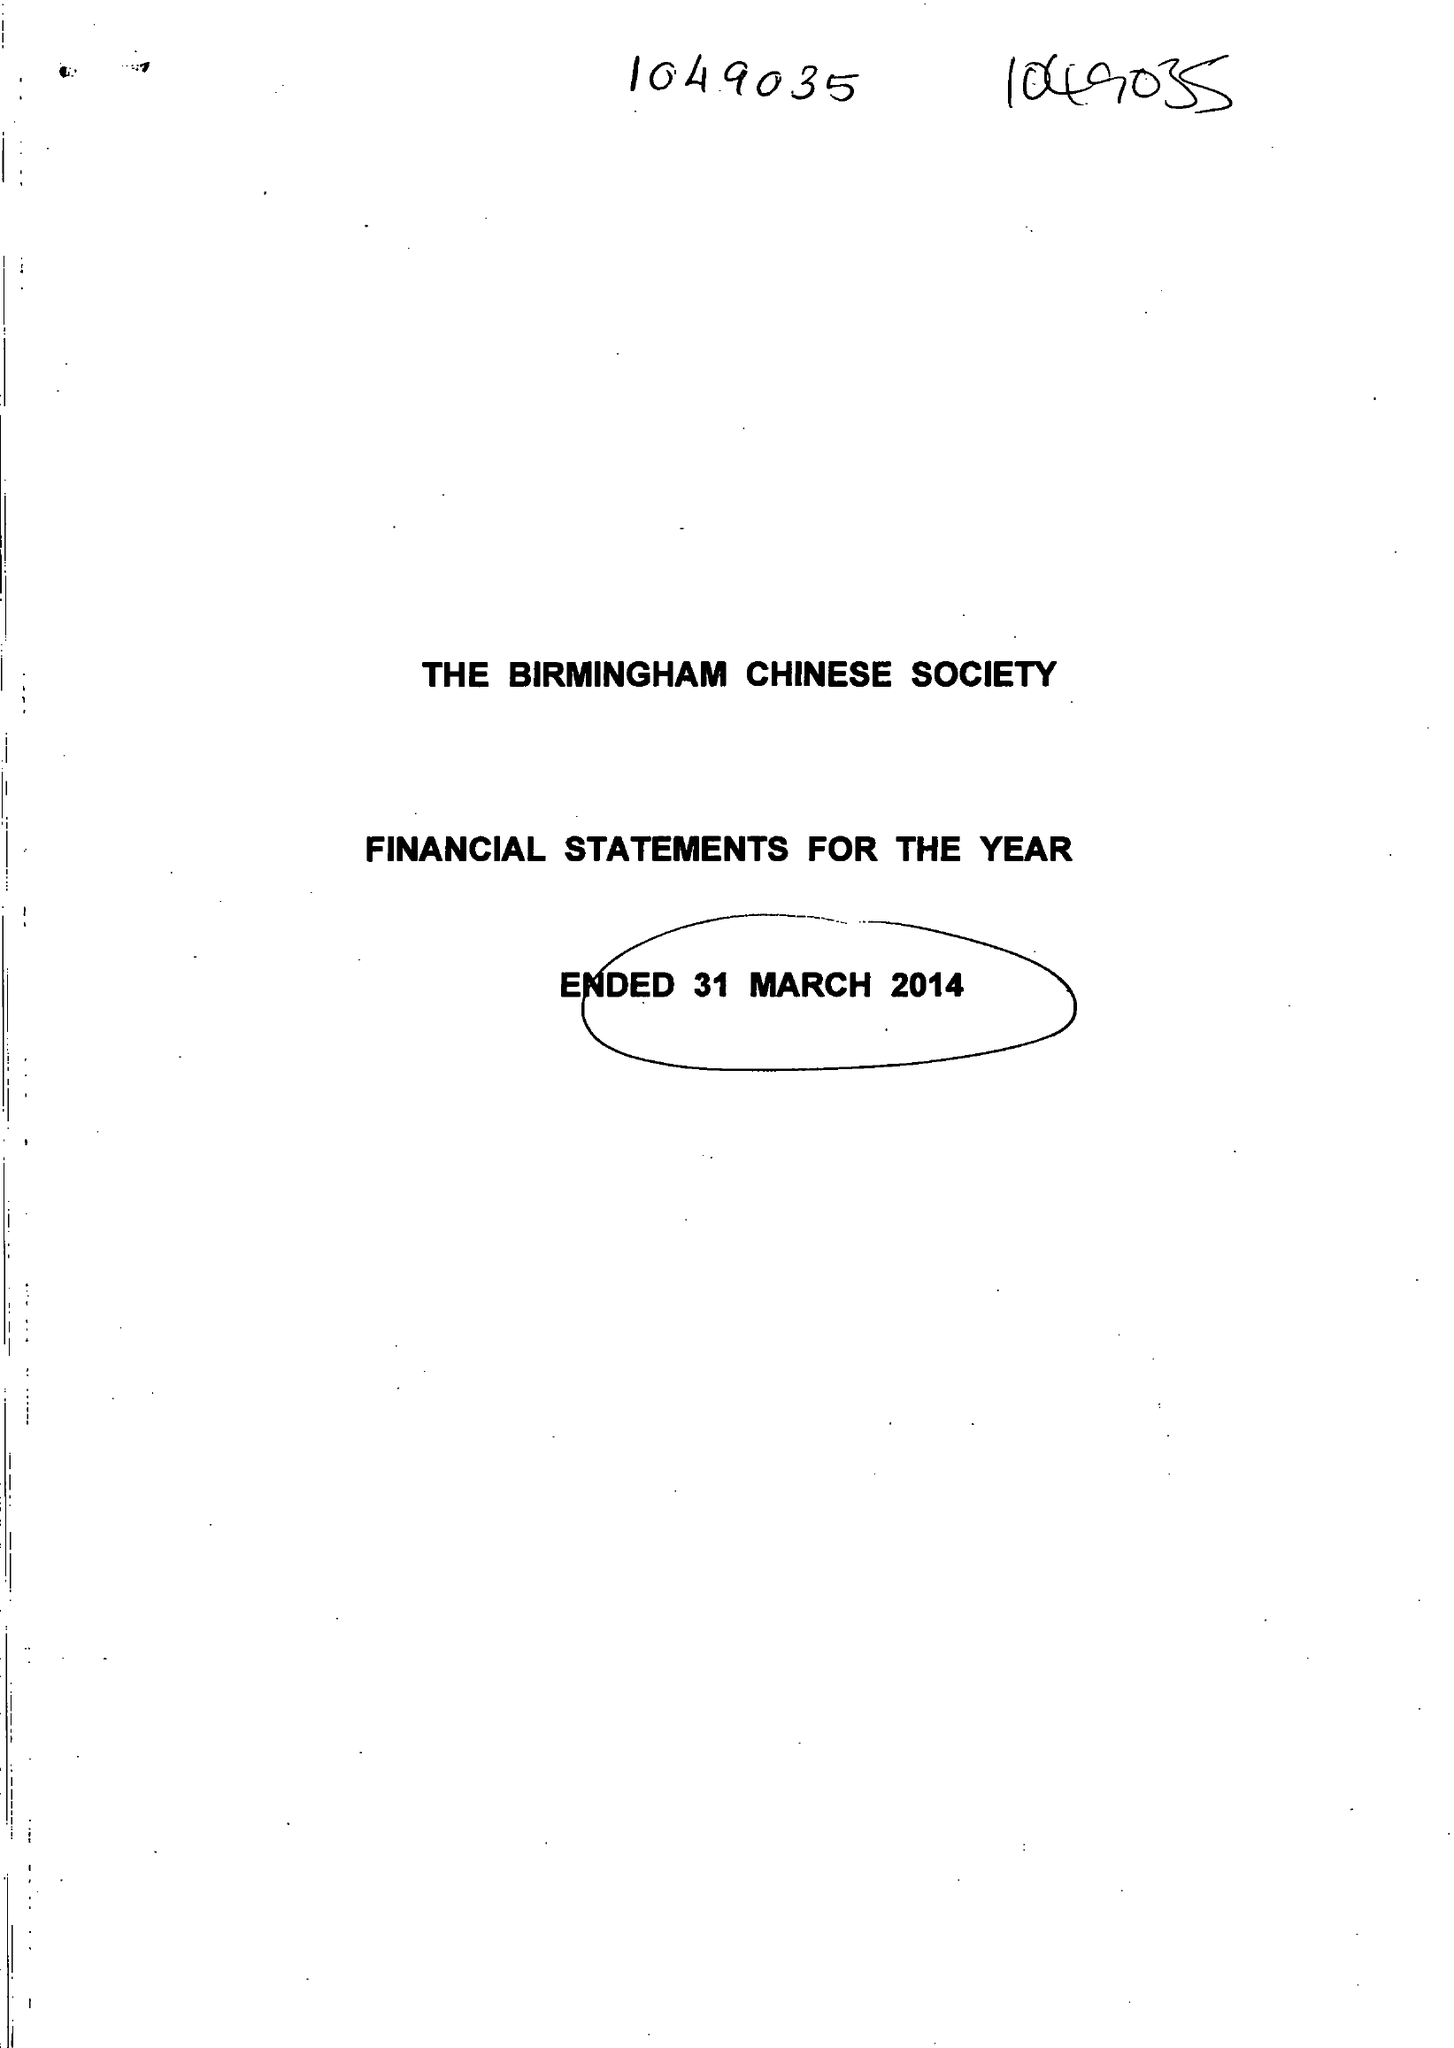What is the value for the address__street_line?
Answer the question using a single word or phrase. 11 ALLCOCK STREET 